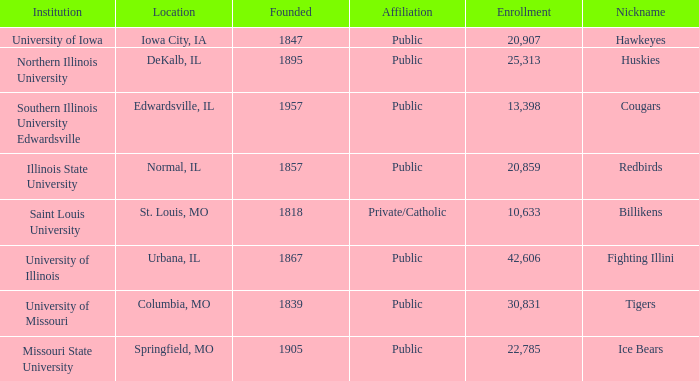What is Southern Illinois University Edwardsville's affiliation? Public. 